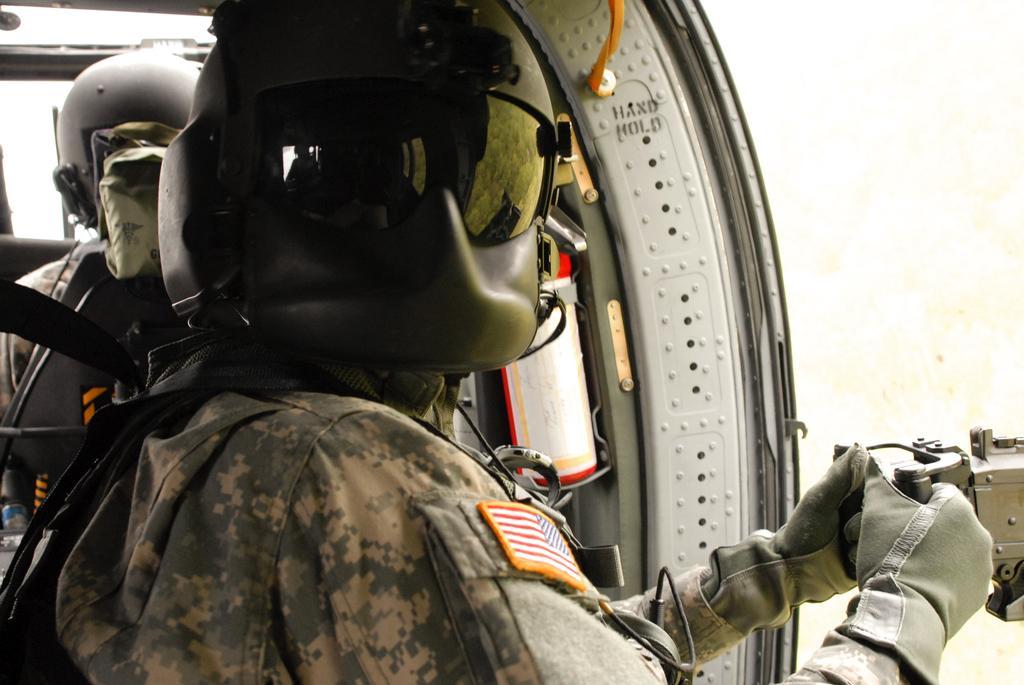Describe this image in one or two sentences. In the center of the image we can see two persons are sitting and they are wearing helmets. And the front person is holding some object. In the background there is a wall and a few other objects. 